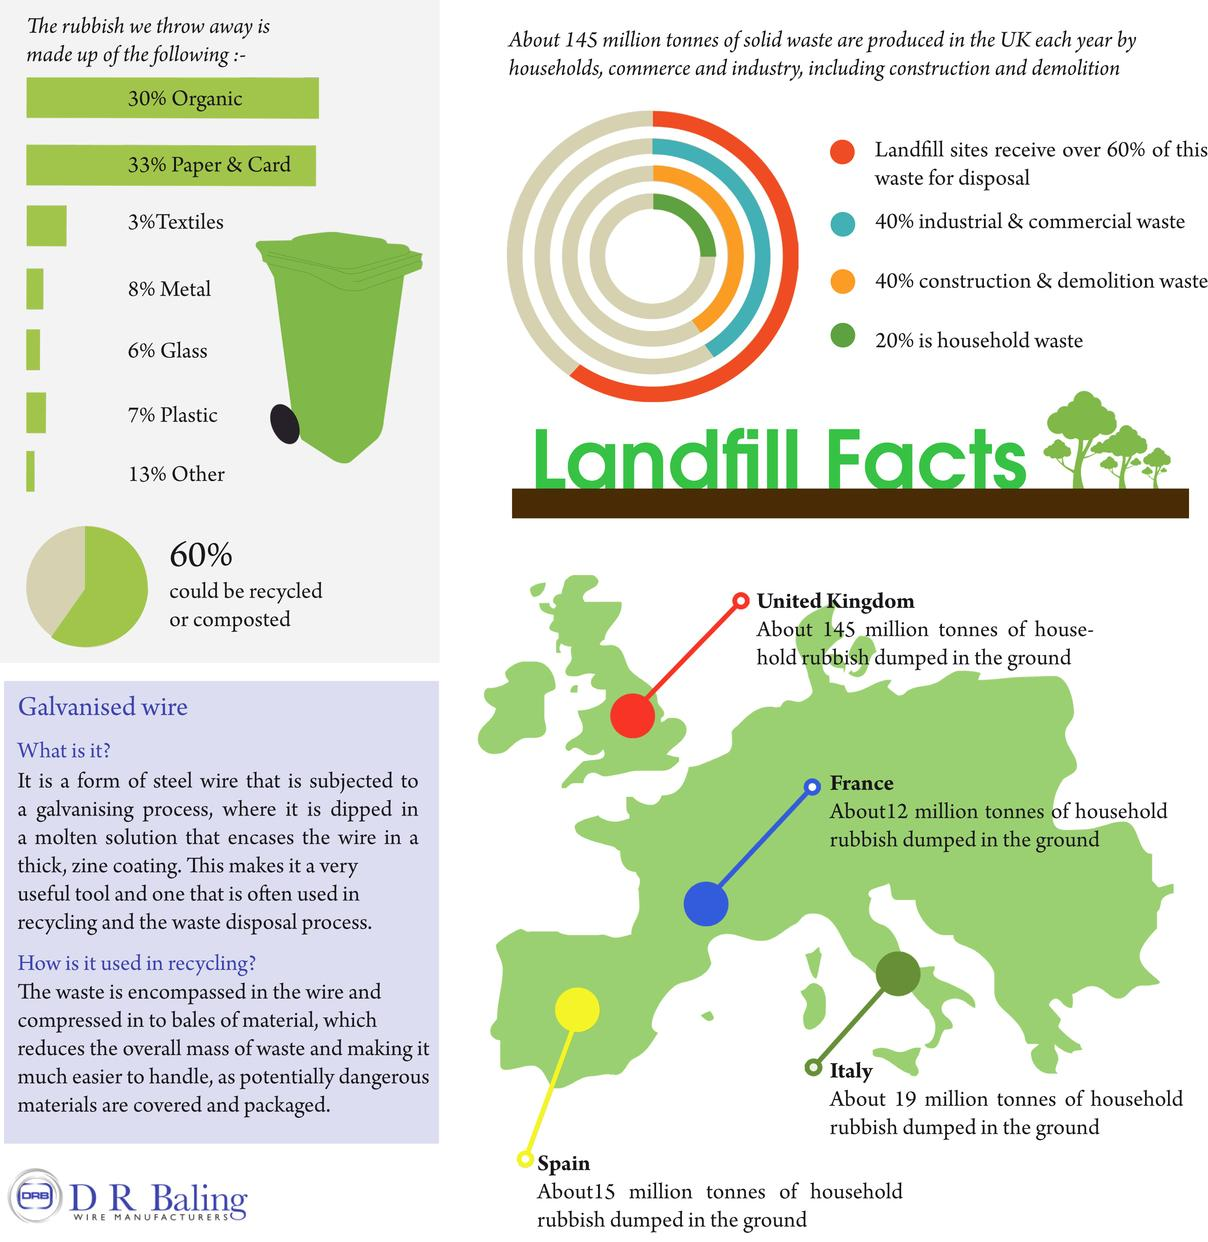Point out several critical features in this image. In Spain, waste dumped by households is indicated by the color yellow on maps. The United Kingdom is the European country that produces the highest amount of household waste, which is dumped in the ground. The metal waste is more than the textile waste by 5%. France has a higher rate of underground rubbish dumping compared to Spain and Italy. Approximately 40% of waste cannot be recycled or composted, but can instead only be disposed of in landfills or other methods that are less environmentally friendly. 